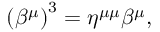<formula> <loc_0><loc_0><loc_500><loc_500>\left ( \beta ^ { \mu } \right ) ^ { 3 } = \eta ^ { \mu \mu } \beta ^ { \mu } ,</formula> 